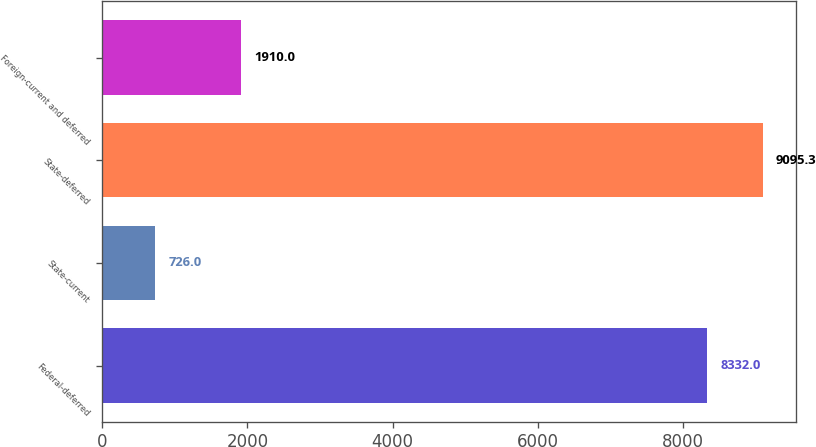<chart> <loc_0><loc_0><loc_500><loc_500><bar_chart><fcel>Federal-deferred<fcel>State-current<fcel>State-deferred<fcel>Foreign-current and deferred<nl><fcel>8332<fcel>726<fcel>9095.3<fcel>1910<nl></chart> 